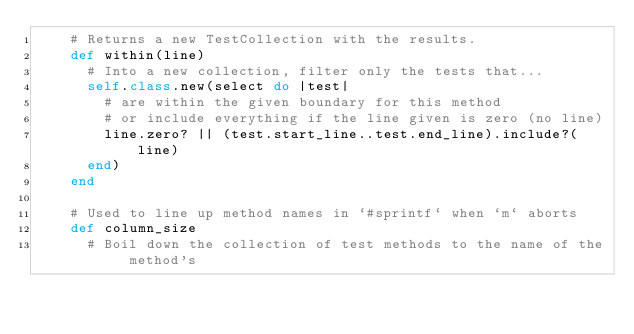Convert code to text. <code><loc_0><loc_0><loc_500><loc_500><_Ruby_>    # Returns a new TestCollection with the results.
    def within(line)
      # Into a new collection, filter only the tests that...
      self.class.new(select do |test|
        # are within the given boundary for this method
        # or include everything if the line given is zero (no line)
        line.zero? || (test.start_line..test.end_line).include?(line)
      end)
    end

    # Used to line up method names in `#sprintf` when `m` aborts
    def column_size
      # Boil down the collection of test methods to the name of the method's</code> 